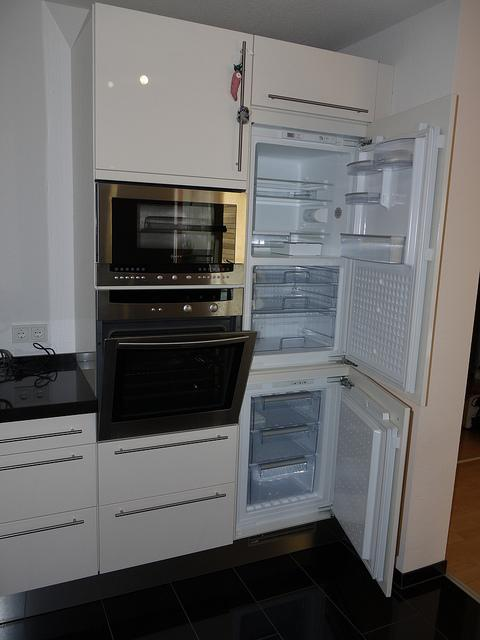The kitchen adheres to the electrical standards set in which region? Please explain your reasoning. europe. The kitchen sets standards to europe's. 